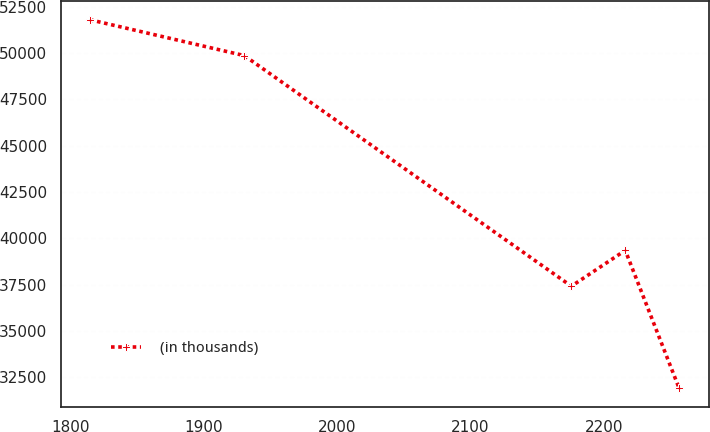<chart> <loc_0><loc_0><loc_500><loc_500><line_chart><ecel><fcel>(in thousands)<nl><fcel>1814.48<fcel>51792.5<nl><fcel>1930.3<fcel>49858.2<nl><fcel>2175.76<fcel>37409.1<nl><fcel>2216.22<fcel>39343.4<nl><fcel>2256.68<fcel>31891.8<nl></chart> 